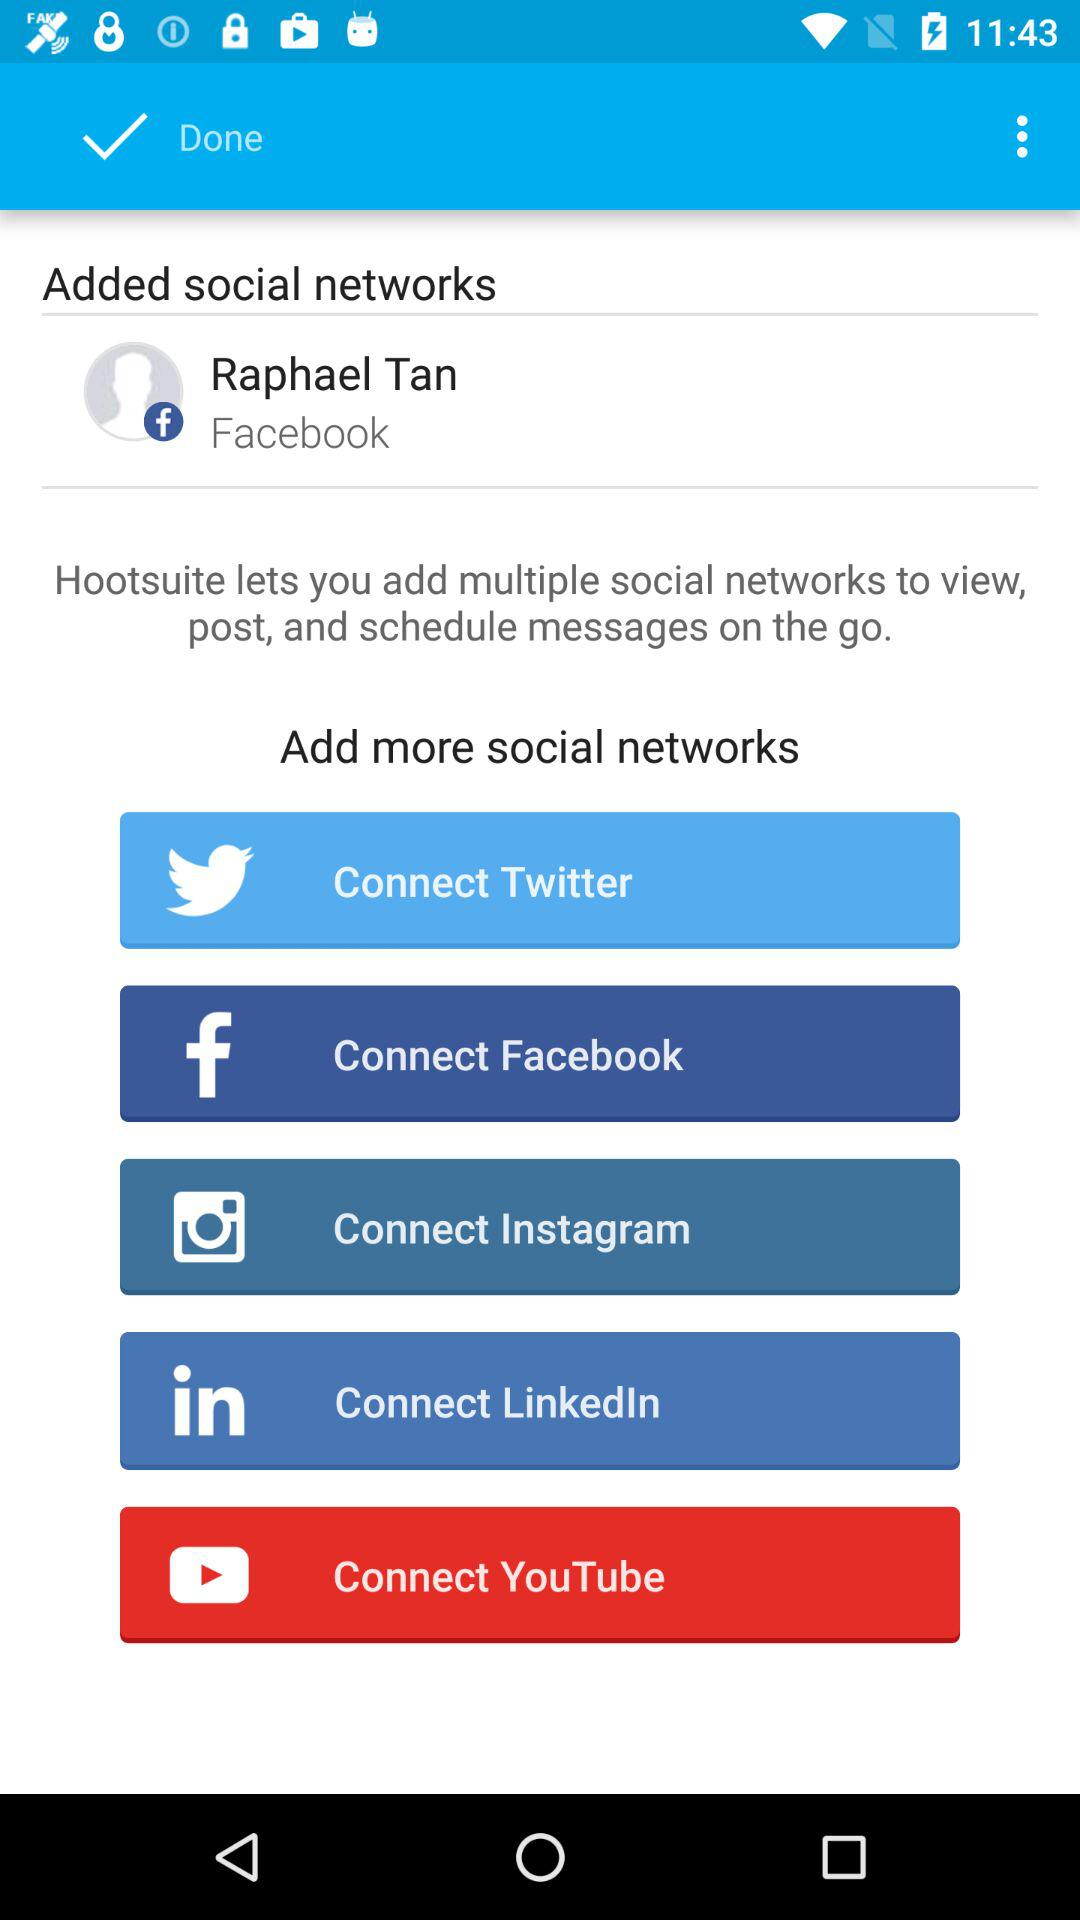What is the user name of the added social network account? The user name of the added social network account is Raphael Tan. 